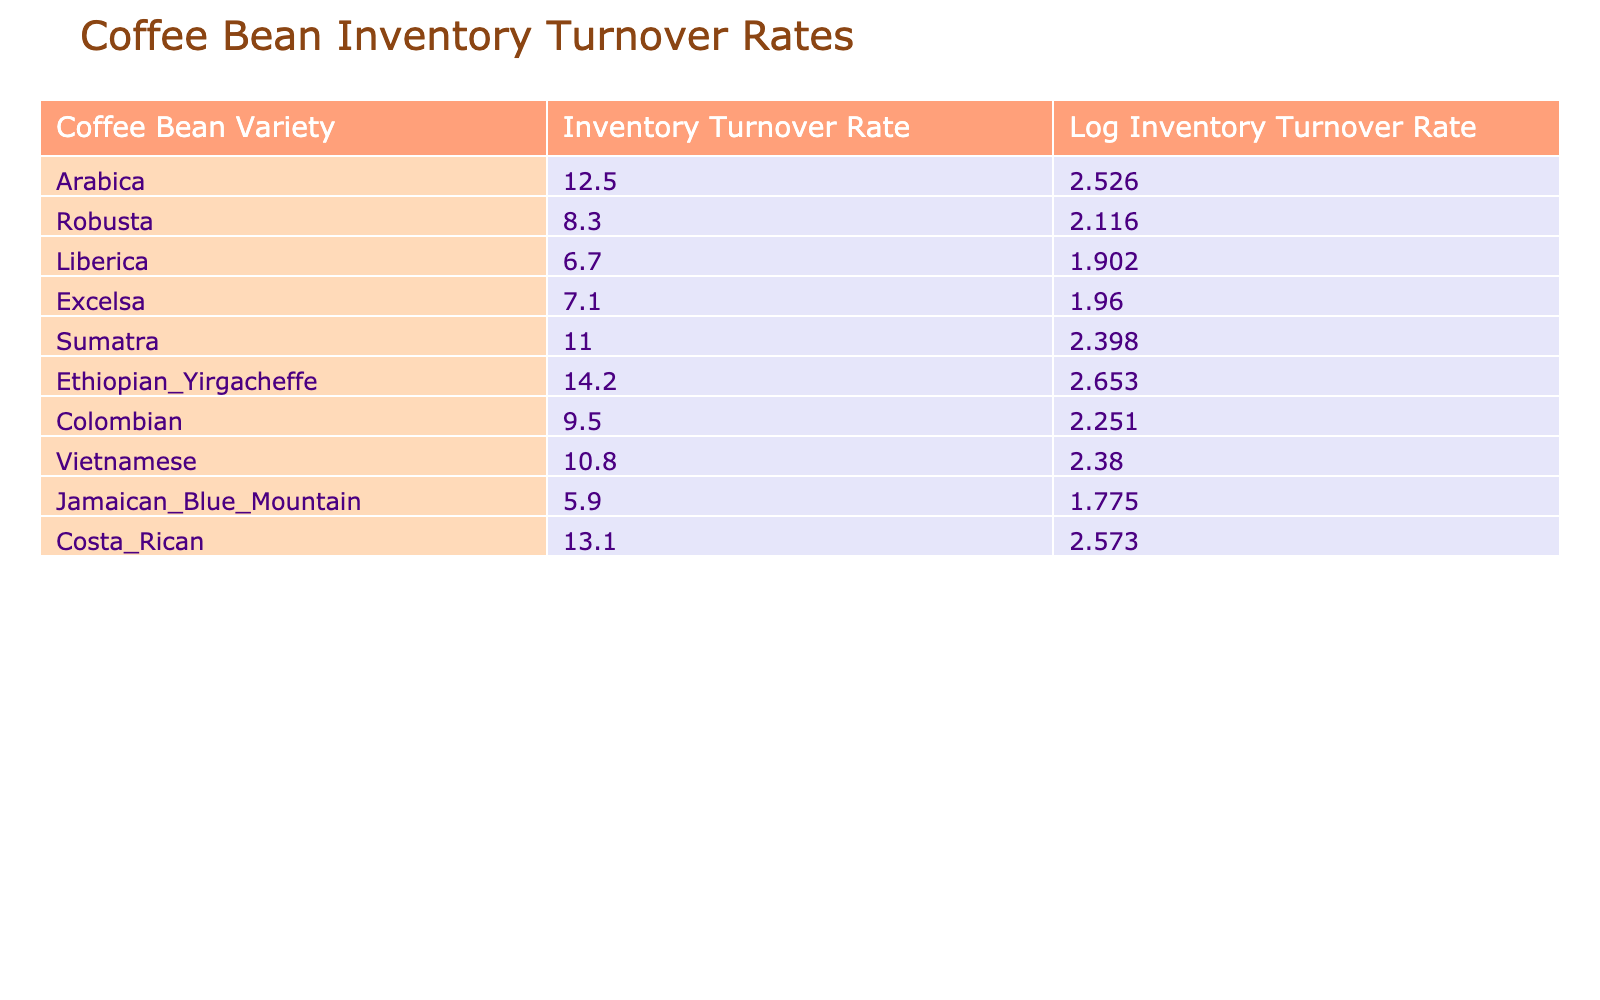What is the inventory turnover rate for Ethiopian Yirgacheffe? The table lists Ethiopian Yirgacheffe with an inventory turnover rate of 14.2.
Answer: 14.2 Which coffee bean variety has the highest inventory turnover rate? Ethiopian Yirgacheffe has the highest inventory turnover rate of 14.2, as noted in the table.
Answer: Ethiopian Yirgacheffe What is the difference in inventory turnover rates between Arabica and Robusta? The inventory turnover rate for Arabica is 12.5 and for Robusta is 8.3. The difference is 12.5 - 8.3 = 4.2.
Answer: 4.2 Are there any coffee varieties with an inventory turnover rate below 7? The table shows that Liberica (6.7) and Jamaican Blue Mountain (5.9) have inventory turnover rates below 7, indicating that the answer is yes.
Answer: Yes What is the average inventory turnover rate for the varieties listed? To find the average, sum all inventory turnover rates: (12.5 + 8.3 + 6.7 + 7.1 + 11 + 14.2 + 9.5 + 10.8 + 5.9 + 13.1) = 88.1, and divide by the number of varieties (10). 88.1 / 10 = 8.81.
Answer: 8.81 Which coffee bean varieties have inventory turnover rates above 10? Looking at the table, the varieties with rates above 10 are Ethiopian Yirgacheffe (14.2), Costa Rican (13.1), and Arabica (12.5).
Answer: Ethiopian Yirgacheffe, Costa Rican, Arabica Is the inventory turnover rate for Sumatra higher than that of Excelsa? The inventory turnover rate for Sumatra is 11.0 while for Excelsa it is 7.1. Since 11.0 is greater than 7.1, the answer is yes.
Answer: Yes What is the total inventory turnover rate for Liberica and Jamaican Blue Mountain? The inventory turnover rates for Liberica (6.7) and Jamaican Blue Mountain (5.9) can be summed: 6.7 + 5.9 = 12.6.
Answer: 12.6 How many coffee varieties have an inventory turnover rate greater than 9? Counting the varieties from the table, the ones above 9 are Arabica, Ethiopian Yirgacheffe, Colombian, Vietnamese, Sumatra, and Costa Rican, which totals 6 varieties.
Answer: 6 